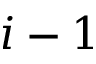<formula> <loc_0><loc_0><loc_500><loc_500>i - 1</formula> 